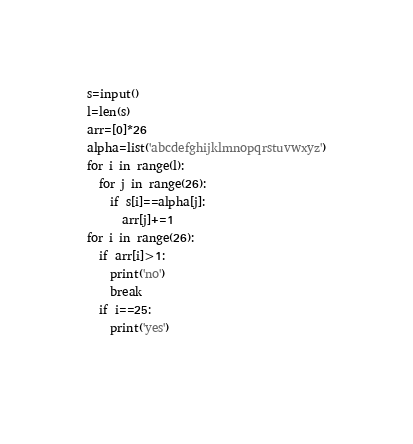<code> <loc_0><loc_0><loc_500><loc_500><_Python_>s=input()
l=len(s)
arr=[0]*26
alpha=list('abcdefghijklmnopqrstuvwxyz')
for i in range(l):
  for j in range(26):
    if s[i]==alpha[j]:
      arr[j]+=1
for i in range(26):
  if arr[i]>1:
    print('no')
    break
  if i==25:
    print('yes')
    </code> 